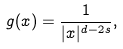<formula> <loc_0><loc_0><loc_500><loc_500>g ( x ) = \frac { 1 } { | x | ^ { d - 2 s } } ,</formula> 